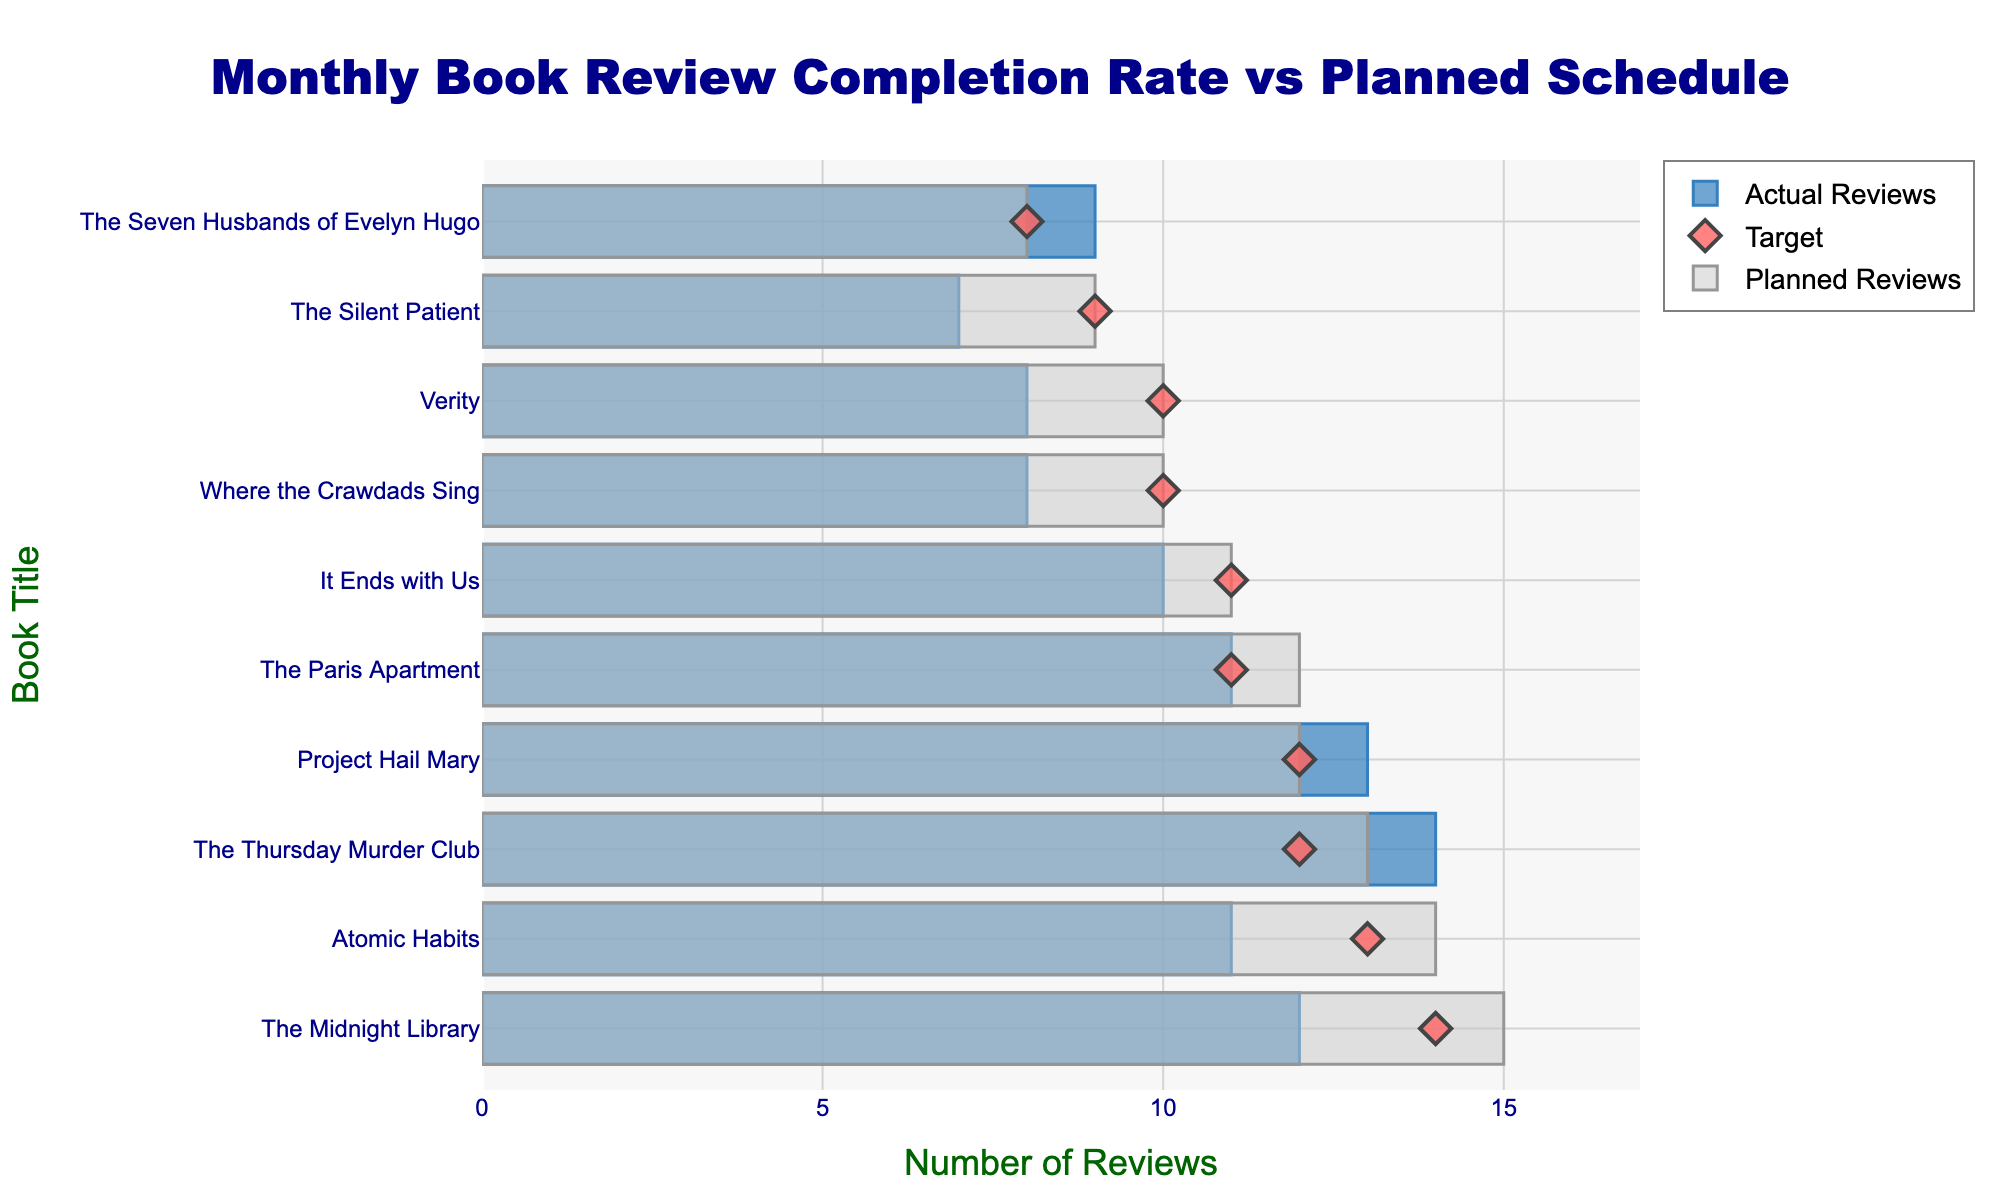What is the title of the chart? The title of the chart is placed prominently at the top and it can be read directly.
Answer: "Monthly Book Review Completion Rate vs Planned Schedule" How many reviews of "The Midnight Library" were planned? Look for "The Midnight Library" in the figure and check its corresponding bar for Planned Reviews, which is usually a lighter color pair.
Answer: 15 Which book had the highest number of actual reviews? Compare the lengths of the bars representing Actual Reviews for all books. The longest bar indicates the highest number of actual reviews.
Answer: "The Thursday Murder Club" How do the actual reviews for "Project Hail Mary" compare to the target? Identify the bar (Actual Reviews) and marker (Target) positions for "Project Hail Mary" and compare the numbers.
Answer: 1 review more than the target For which book(s) did the actual number of reviews match the targets? Check the positions of both the Actual Reviews bar and Target marker for all books to identify matches.
Answer: "Project Hail Mary", "The Seven Husbands of Evelyn Hugo", "It Ends with Us" Which book had the greatest shortfall in actual reviews compared to what was planned? Calculate the difference between Planned Reviews and Actual Reviews for each book, and identify the largest positive difference.
Answer: "The Midnight Library" (3 reviews short) What is the total number of planned reviews for "The Paris Apartment" and "Verity"? Add the Planned Reviews for "The Paris Apartment" and "Verity" together.
Answer: 22 (12 + 10) How short was "Atomic Habits" in actual reviews compared to its target? Subtract the Target for "Atomic Habits" from its Actual Reviews.
Answer: 2 reviews short (11 - 13) Which book exceeded its planned reviews in actual reviews? Compare the Actual Reviews and Planned Reviews for all books and identify any instance where Actual Reviews are greater.
Answer: "The Thursday Murder Club" What is the average planned review count for all books? Sum all the Planned Reviews and divide by the number of books.
Answer: (15 + 12 + 10 + 8 + 14 + 11 + 9 + 13 + 10 + 12) / 10 = 10.4 